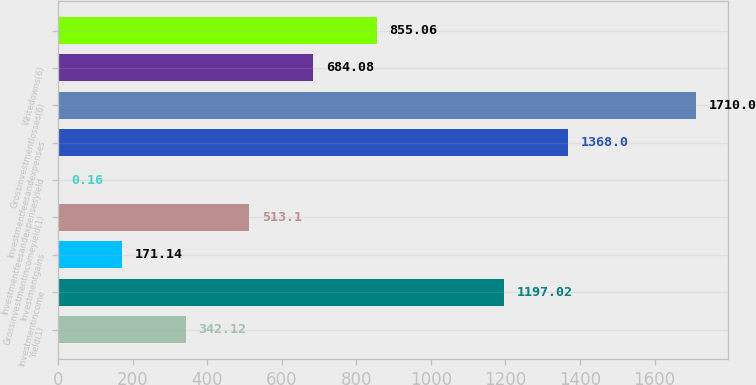<chart> <loc_0><loc_0><loc_500><loc_500><bar_chart><fcel>Yield(1)<fcel>Investmentincome<fcel>Investmentgains<fcel>Grossinvestmentincomeyield(1)<fcel>Investmentfeesandexpensesyield<fcel>Investmentfeesandexpenses<fcel>Grossinvestmentlosses(6)<fcel>Writedowns(6)<fcel>Unnamed: 8<nl><fcel>342.12<fcel>1197.02<fcel>171.14<fcel>513.1<fcel>0.16<fcel>1368<fcel>1710<fcel>684.08<fcel>855.06<nl></chart> 